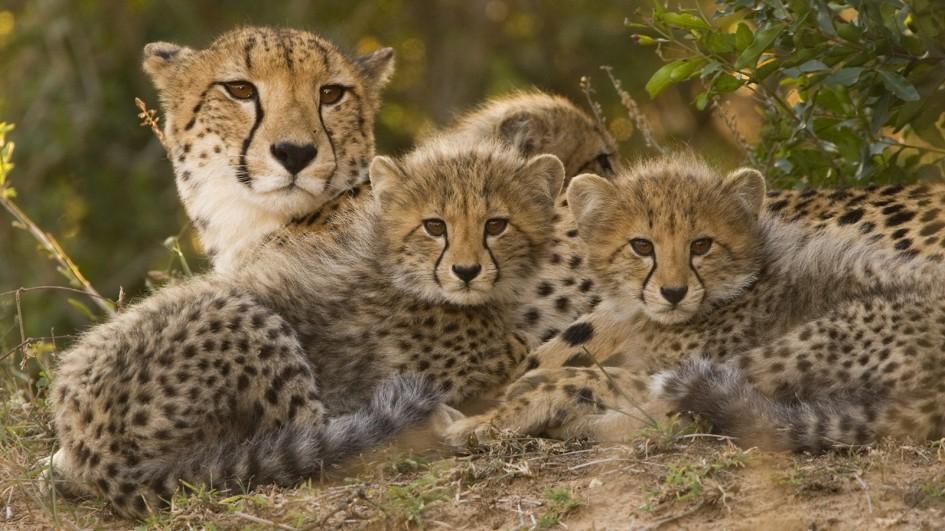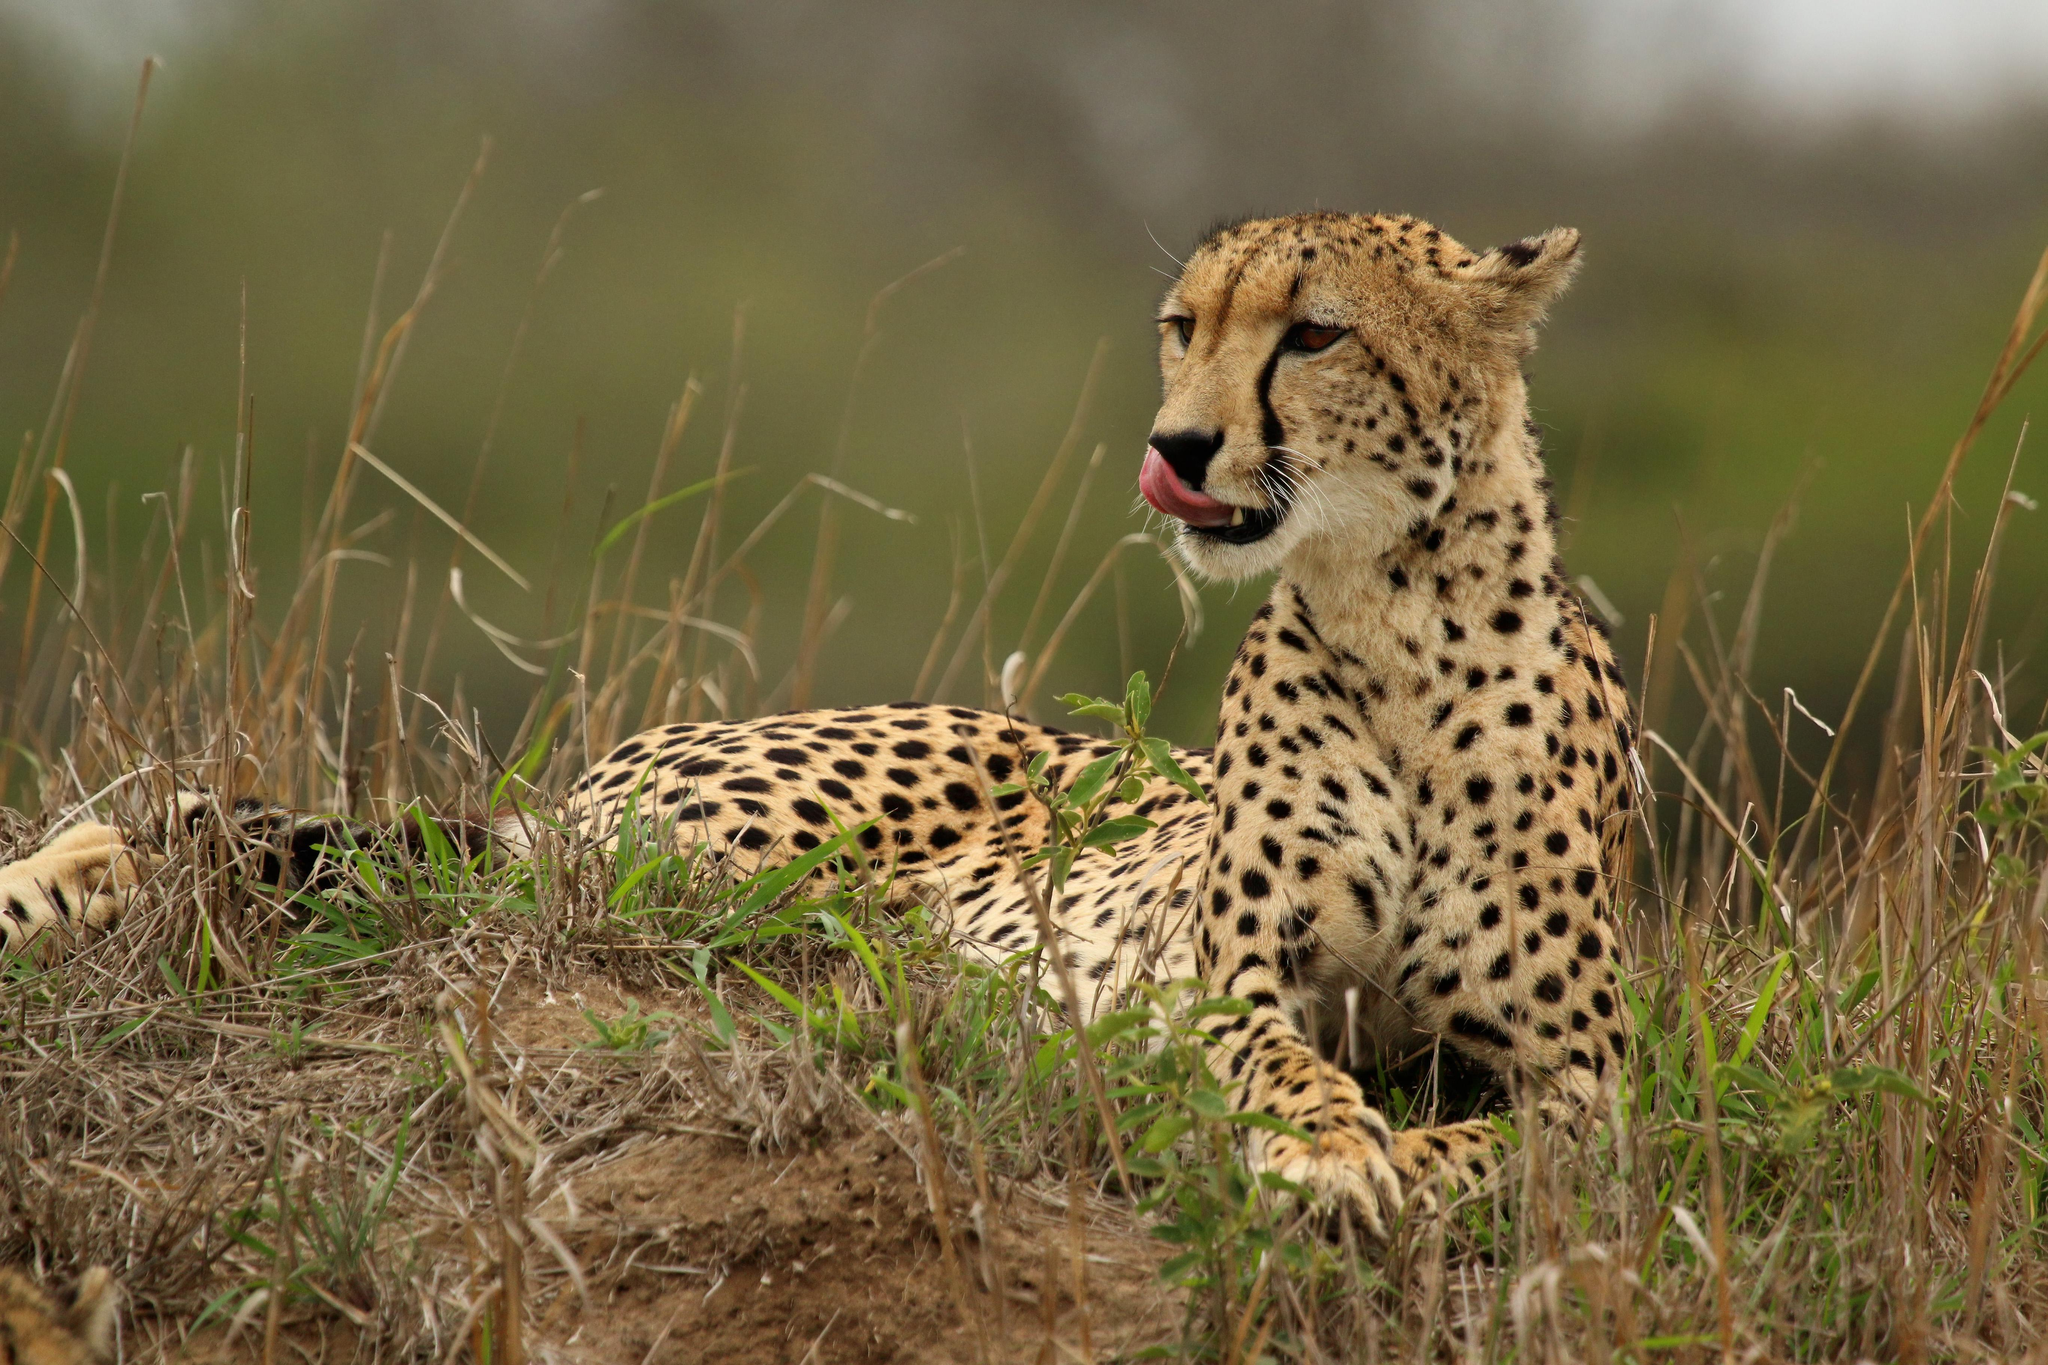The first image is the image on the left, the second image is the image on the right. Given the left and right images, does the statement "The cheetah on the right image is a close up of its face while looking at the camera." hold true? Answer yes or no. No. 